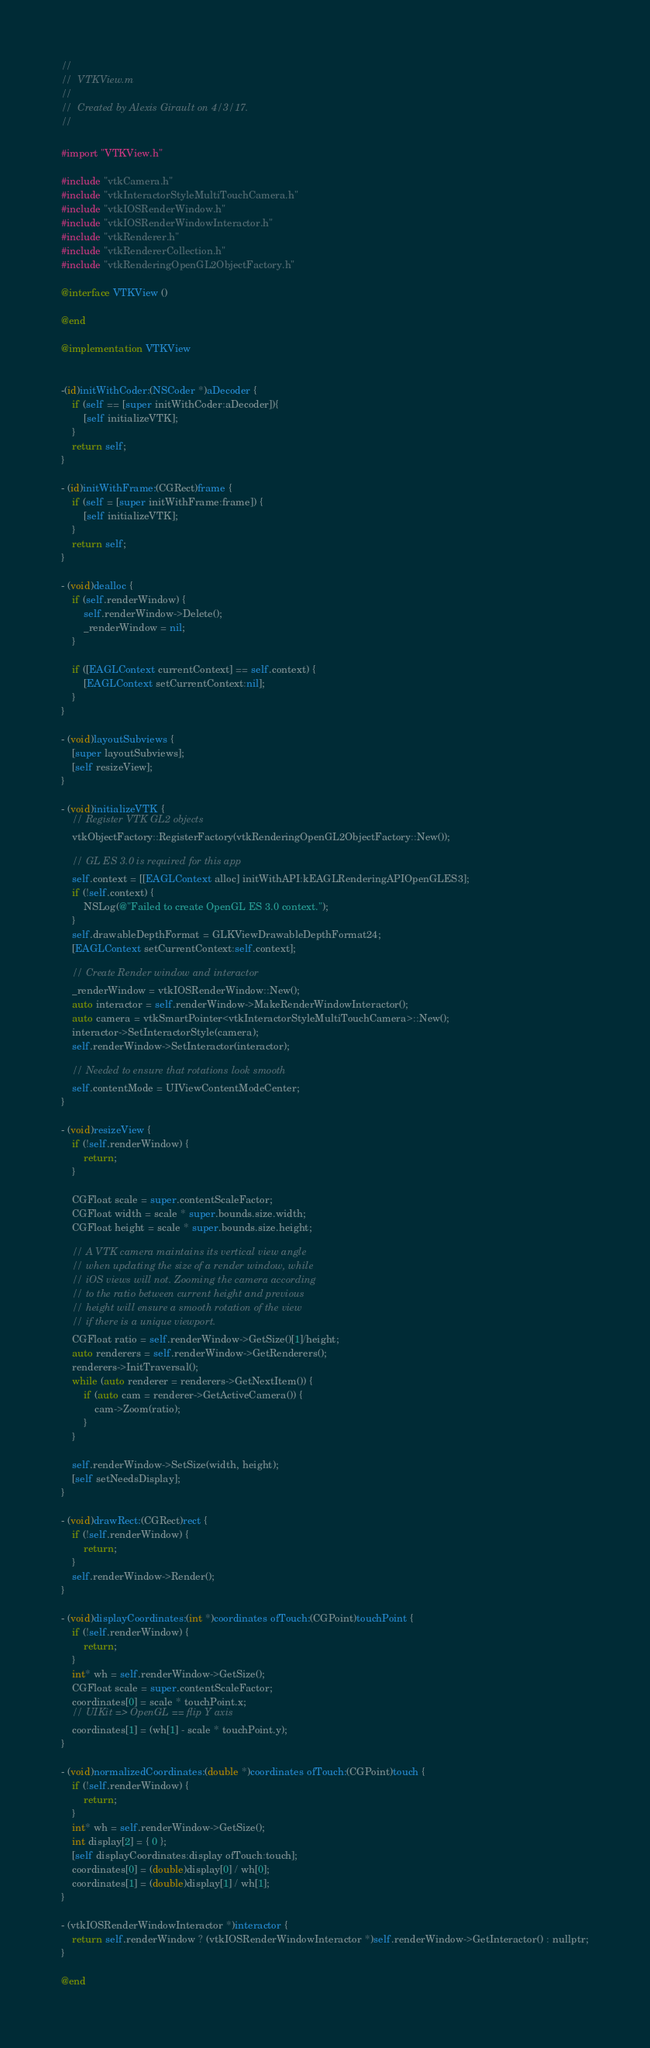Convert code to text. <code><loc_0><loc_0><loc_500><loc_500><_ObjectiveC_>//
//  VTKView.m
//
//  Created by Alexis Girault on 4/3/17.
//

#import "VTKView.h"

#include "vtkCamera.h"
#include "vtkInteractorStyleMultiTouchCamera.h"
#include "vtkIOSRenderWindow.h"
#include "vtkIOSRenderWindowInteractor.h"
#include "vtkRenderer.h"
#include "vtkRendererCollection.h"
#include "vtkRenderingOpenGL2ObjectFactory.h"

@interface VTKView ()

@end

@implementation VTKView


-(id)initWithCoder:(NSCoder *)aDecoder {
    if (self == [super initWithCoder:aDecoder]){
        [self initializeVTK];
    }
    return self;
}

- (id)initWithFrame:(CGRect)frame {
    if (self = [super initWithFrame:frame]) {
        [self initializeVTK];
    }
    return self;
}

- (void)dealloc {
    if (self.renderWindow) {
        self.renderWindow->Delete();
        _renderWindow = nil;
    }

    if ([EAGLContext currentContext] == self.context) {
        [EAGLContext setCurrentContext:nil];
    }
}

- (void)layoutSubviews {
    [super layoutSubviews];
    [self resizeView];
}

- (void)initializeVTK {
    // Register VTK GL2 objects
    vtkObjectFactory::RegisterFactory(vtkRenderingOpenGL2ObjectFactory::New());

    // GL ES 3.0 is required for this app
    self.context = [[EAGLContext alloc] initWithAPI:kEAGLRenderingAPIOpenGLES3];
    if (!self.context) {
        NSLog(@"Failed to create OpenGL ES 3.0 context.");
    }
    self.drawableDepthFormat = GLKViewDrawableDepthFormat24;
    [EAGLContext setCurrentContext:self.context];

    // Create Render window and interactor
    _renderWindow = vtkIOSRenderWindow::New();
    auto interactor = self.renderWindow->MakeRenderWindowInteractor();
    auto camera = vtkSmartPointer<vtkInteractorStyleMultiTouchCamera>::New();
    interactor->SetInteractorStyle(camera);
    self.renderWindow->SetInteractor(interactor);

    // Needed to ensure that rotations look smooth
    self.contentMode = UIViewContentModeCenter;
}

- (void)resizeView {
    if (!self.renderWindow) {
        return;
    }

    CGFloat scale = super.contentScaleFactor;
    CGFloat width = scale * super.bounds.size.width;
    CGFloat height = scale * super.bounds.size.height;

    // A VTK camera maintains its vertical view angle
    // when updating the size of a render window, while
    // iOS views will not. Zooming the camera according
    // to the ratio between current height and previous
    // height will ensure a smooth rotation of the view
    // if there is a unique viewport.
    CGFloat ratio = self.renderWindow->GetSize()[1]/height;
    auto renderers = self.renderWindow->GetRenderers();
    renderers->InitTraversal();
    while (auto renderer = renderers->GetNextItem()) {
        if (auto cam = renderer->GetActiveCamera()) {
            cam->Zoom(ratio);
        }
    }

    self.renderWindow->SetSize(width, height);
    [self setNeedsDisplay];
}

- (void)drawRect:(CGRect)rect {
    if (!self.renderWindow) {
        return;
    }
    self.renderWindow->Render();
}

- (void)displayCoordinates:(int *)coordinates ofTouch:(CGPoint)touchPoint {
    if (!self.renderWindow) {
        return;
    }
    int* wh = self.renderWindow->GetSize();
    CGFloat scale = super.contentScaleFactor;
    coordinates[0] = scale * touchPoint.x;
    // UIKit => OpenGL == flip Y axis
    coordinates[1] = (wh[1] - scale * touchPoint.y);
}

- (void)normalizedCoordinates:(double *)coordinates ofTouch:(CGPoint)touch {
    if (!self.renderWindow) {
        return;
    }
    int* wh = self.renderWindow->GetSize();
    int display[2] = { 0 };
    [self displayCoordinates:display ofTouch:touch];
    coordinates[0] = (double)display[0] / wh[0];
    coordinates[1] = (double)display[1] / wh[1];
}

- (vtkIOSRenderWindowInteractor *)interactor {
    return self.renderWindow ? (vtkIOSRenderWindowInteractor *)self.renderWindow->GetInteractor() : nullptr;
}

@end
</code> 